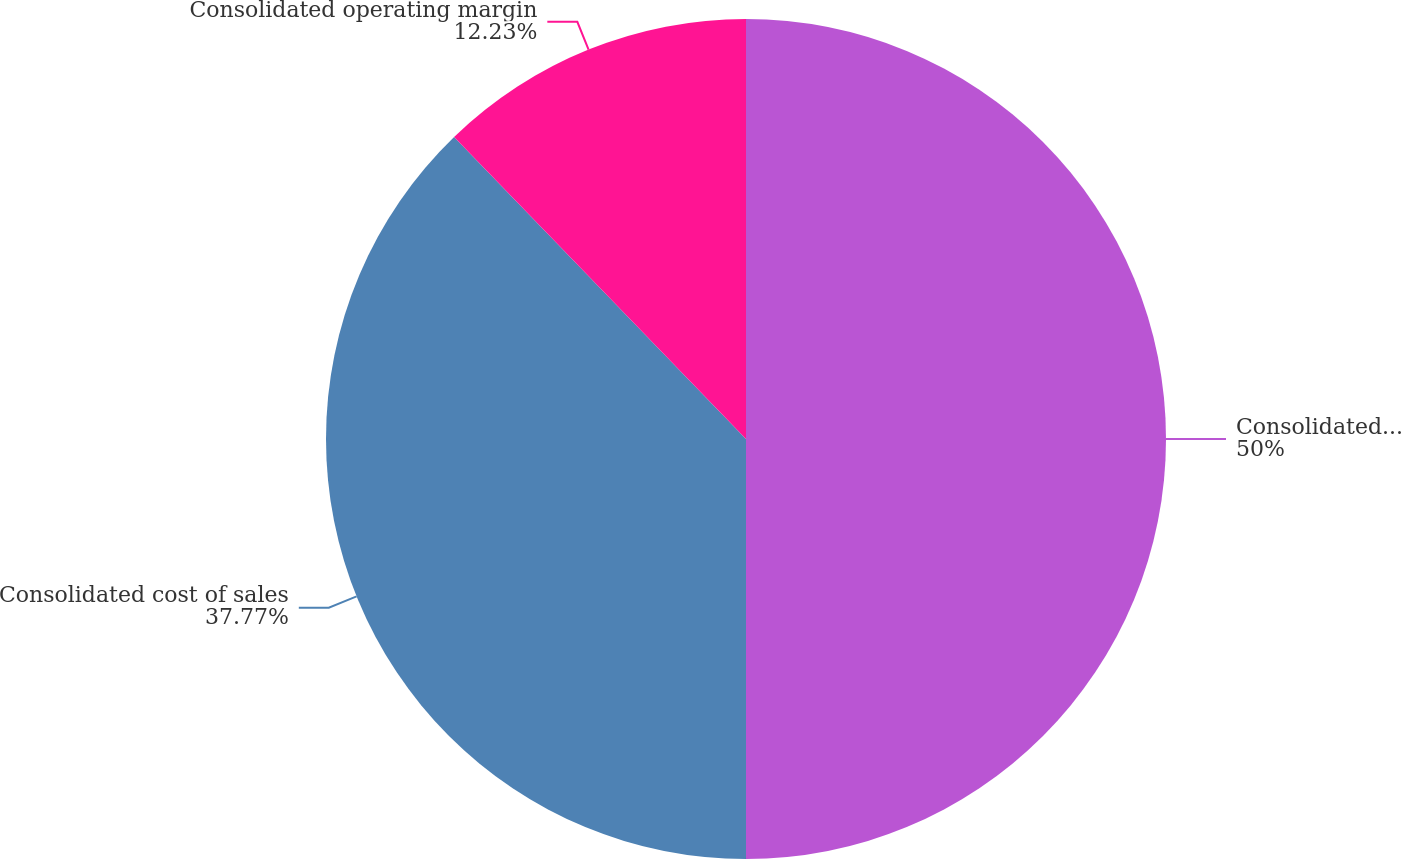Convert chart to OTSL. <chart><loc_0><loc_0><loc_500><loc_500><pie_chart><fcel>Consolidated revenues<fcel>Consolidated cost of sales<fcel>Consolidated operating margin<nl><fcel>50.0%<fcel>37.77%<fcel>12.23%<nl></chart> 